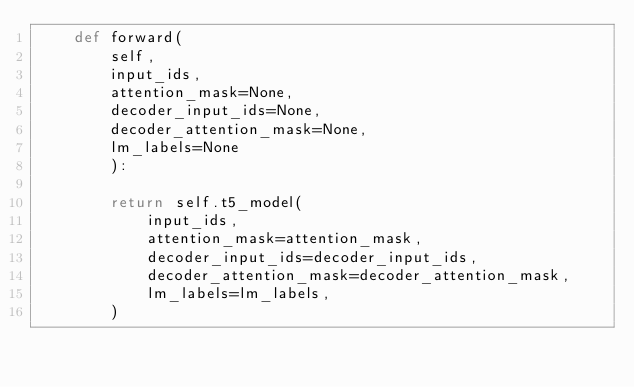<code> <loc_0><loc_0><loc_500><loc_500><_Python_>    def forward(
        self,
        input_ids, 
        attention_mask=None, 
        decoder_input_ids=None, 
        decoder_attention_mask=None, 
        lm_labels=None
        ):

        return self.t5_model(
            input_ids,
            attention_mask=attention_mask,
            decoder_input_ids=decoder_input_ids,
            decoder_attention_mask=decoder_attention_mask,
            lm_labels=lm_labels,
        )</code> 